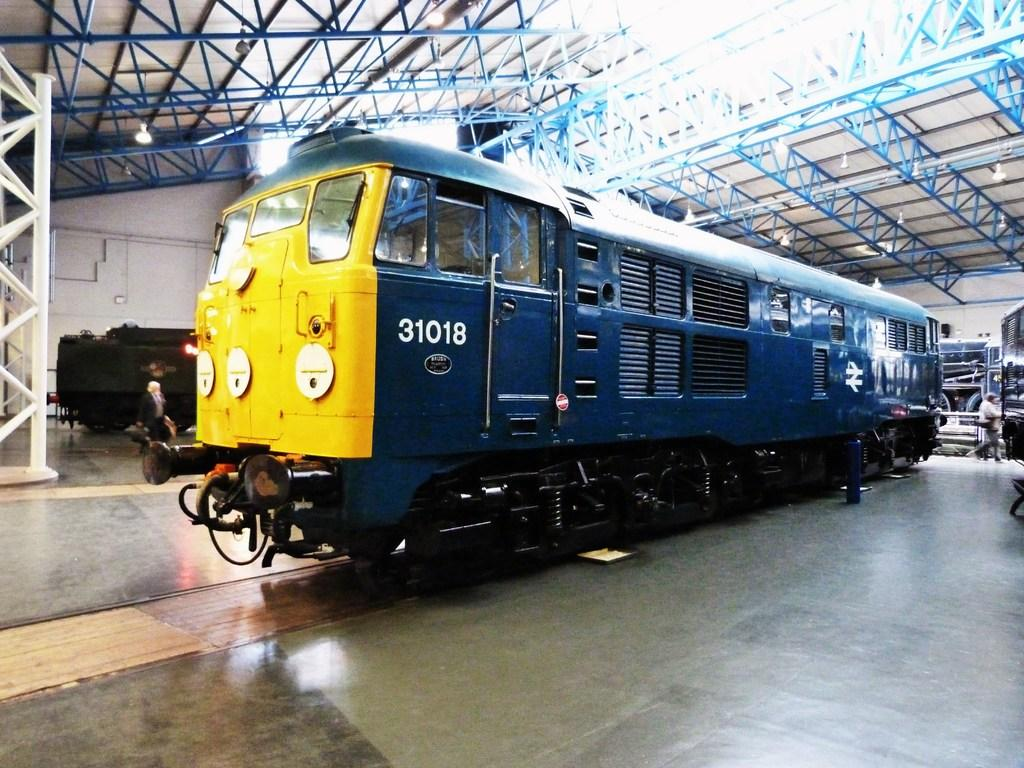<image>
Write a terse but informative summary of the picture. A blue train with the number 31018 on its side is inside a building. 